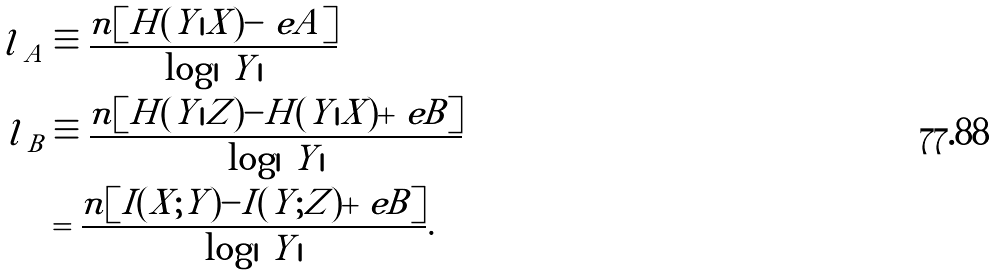Convert formula to latex. <formula><loc_0><loc_0><loc_500><loc_500>l _ { \ A } & \equiv \frac { n [ H ( Y | X ) - \ e A ] } { \log | \ Y | } \\ l _ { \ B } & \equiv \frac { n [ H ( Y | Z ) - H ( Y | X ) + \ e B ] } { \log | \ Y | } \\ & = \frac { n [ I ( X ; Y ) - I ( Y ; Z ) + \ e B ] } { \log | \ Y | } .</formula> 